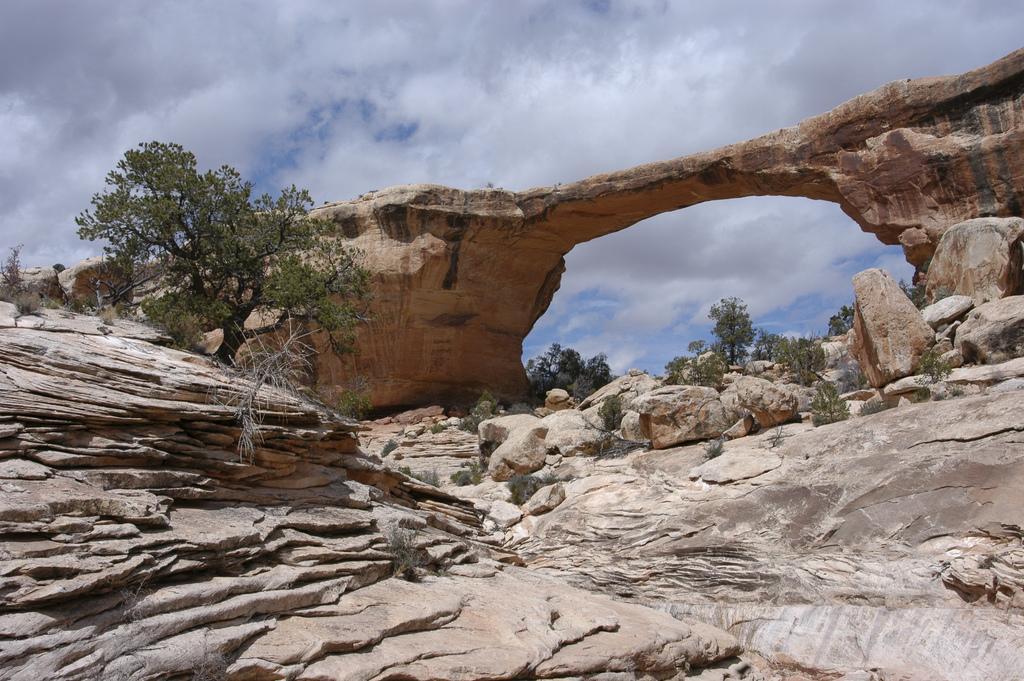Can you describe this image briefly? This is the owachomo bridge. These are the rocks. I can see the trees and plants. These are the clouds in the sky. 